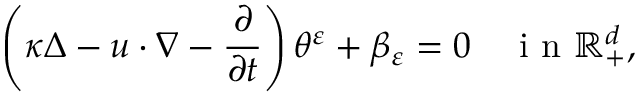<formula> <loc_0><loc_0><loc_500><loc_500>\left ( \kappa \Delta - u \cdot \nabla - \frac { \partial } { \partial t } \right ) \theta ^ { \varepsilon } + \beta _ { \varepsilon } = 0 \quad i n \mathbb { R } _ { + } ^ { d } ,</formula> 